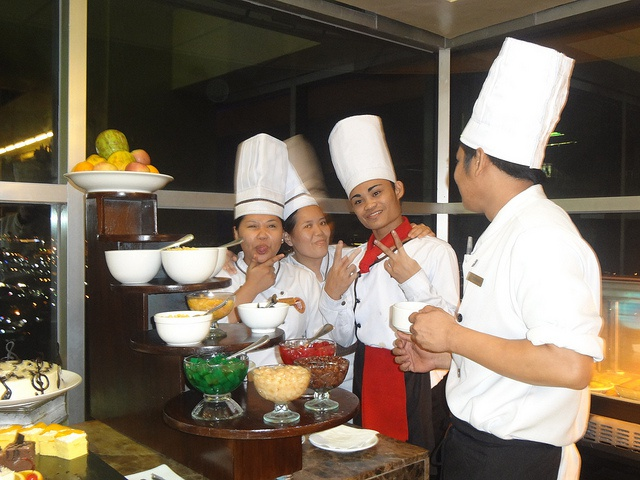Describe the objects in this image and their specific colors. I can see people in black, white, and tan tones, people in black, lightgray, brown, and gray tones, people in black, lightgray, gray, and tan tones, people in black, gray, lightgray, and tan tones, and bowl in black, darkgreen, and gray tones in this image. 